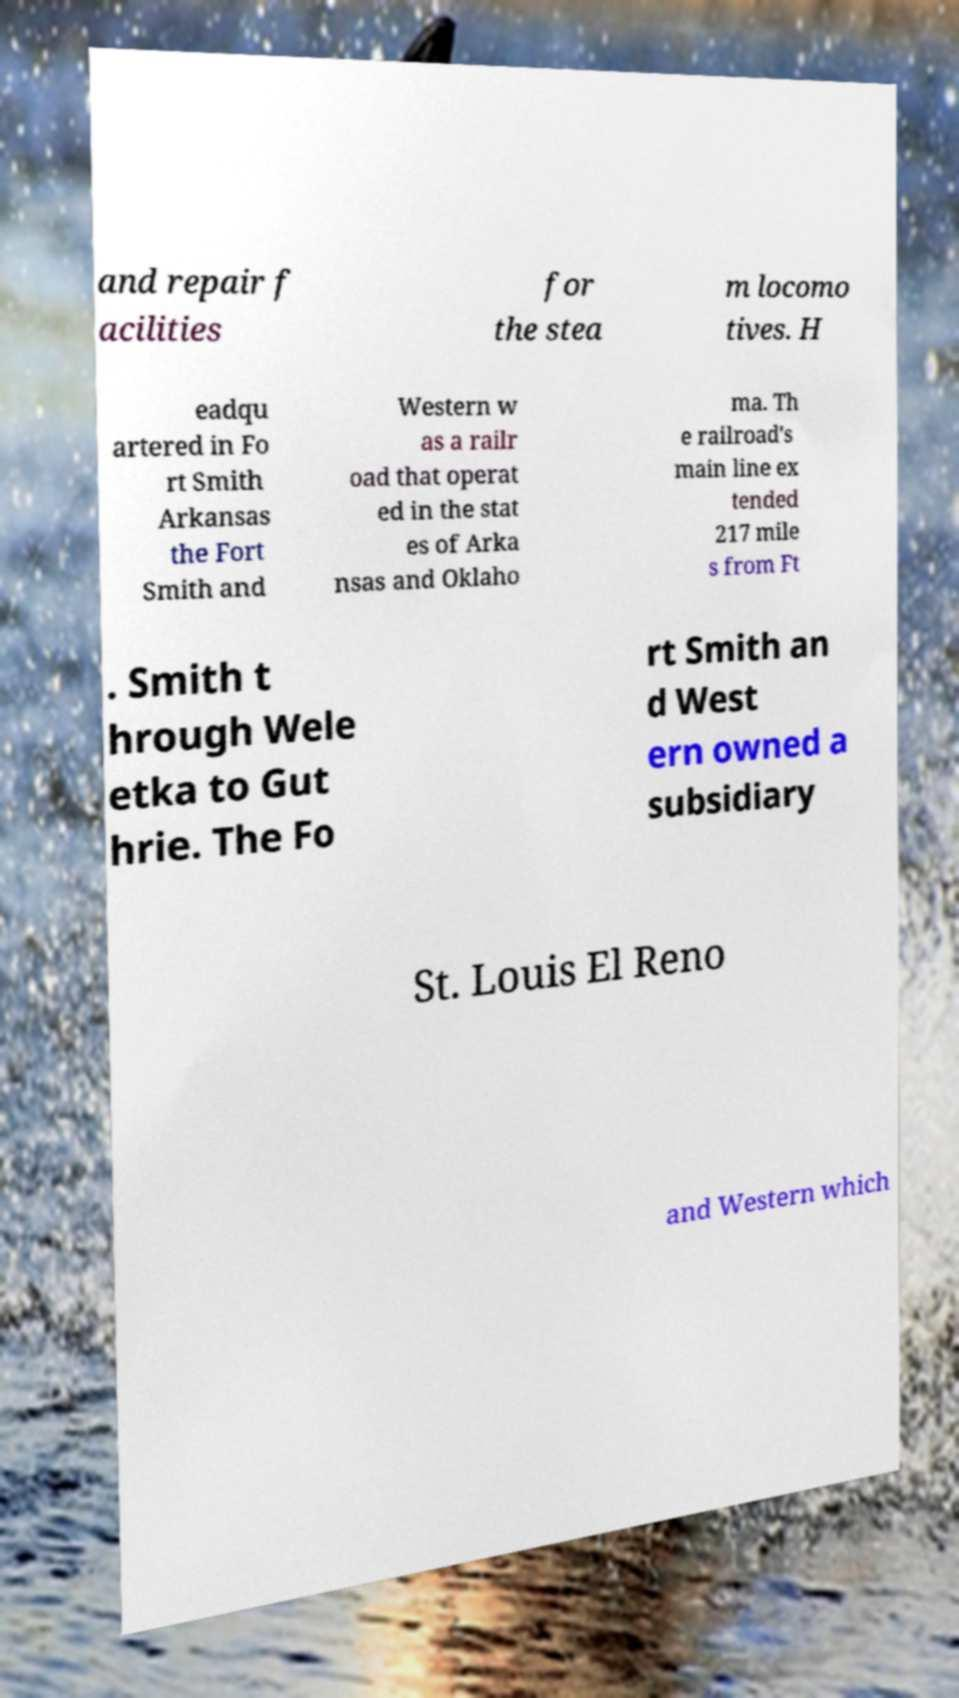Please read and relay the text visible in this image. What does it say? and repair f acilities for the stea m locomo tives. H eadqu artered in Fo rt Smith Arkansas the Fort Smith and Western w as a railr oad that operat ed in the stat es of Arka nsas and Oklaho ma. Th e railroad's main line ex tended 217 mile s from Ft . Smith t hrough Wele etka to Gut hrie. The Fo rt Smith an d West ern owned a subsidiary St. Louis El Reno and Western which 